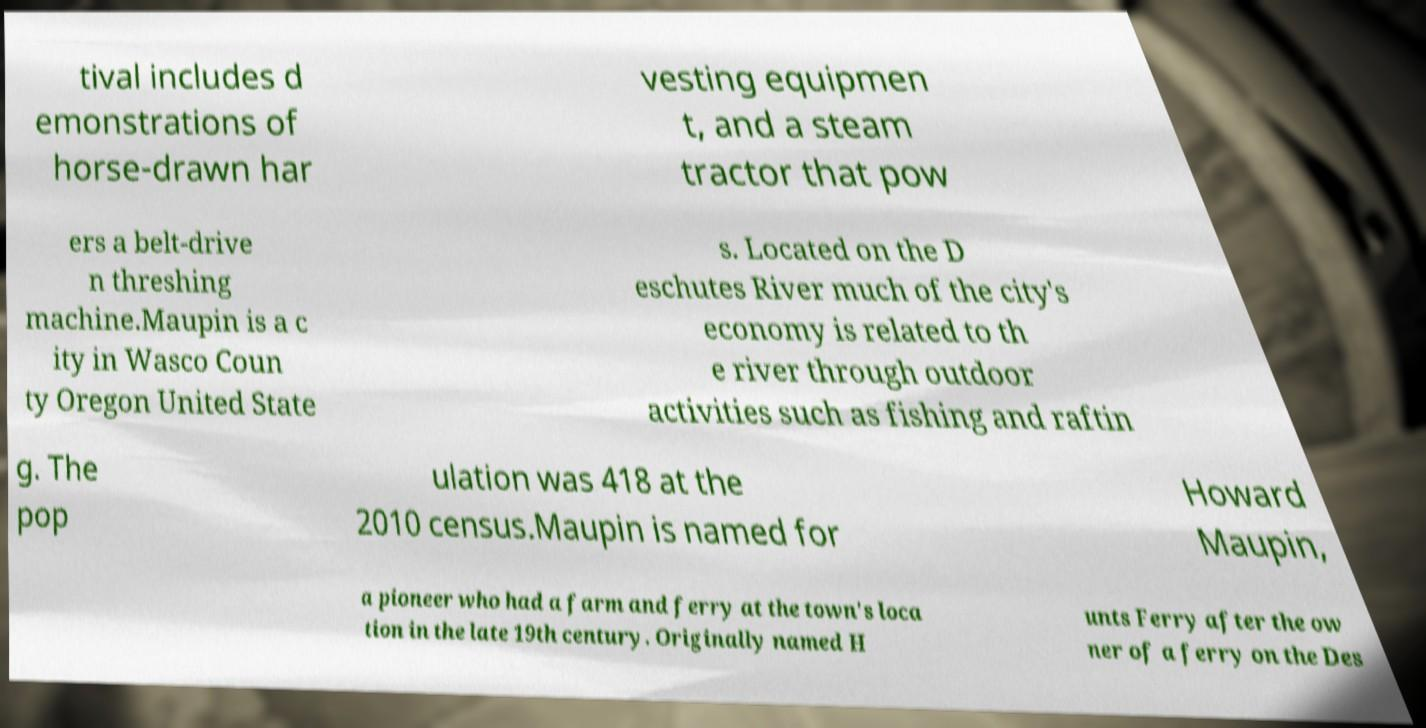Can you accurately transcribe the text from the provided image for me? tival includes d emonstrations of horse-drawn har vesting equipmen t, and a steam tractor that pow ers a belt-drive n threshing machine.Maupin is a c ity in Wasco Coun ty Oregon United State s. Located on the D eschutes River much of the city's economy is related to th e river through outdoor activities such as fishing and raftin g. The pop ulation was 418 at the 2010 census.Maupin is named for Howard Maupin, a pioneer who had a farm and ferry at the town's loca tion in the late 19th century. Originally named H unts Ferry after the ow ner of a ferry on the Des 